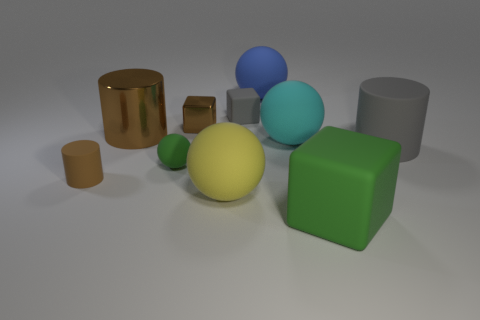There is a rubber ball to the left of the tiny brown metallic thing; is its color the same as the big block?
Your answer should be compact. Yes. There is a thing that is the same color as the big rubber block; what is its material?
Ensure brevity in your answer.  Rubber. What number of large matte objects are the same color as the small rubber ball?
Make the answer very short. 1. What is the size of the rubber object that is the same color as the small shiny object?
Your answer should be compact. Small. There is a sphere right of the big matte thing that is behind the big metal cylinder; what is its material?
Make the answer very short. Rubber. There is a large rubber object right of the cube that is to the right of the small rubber thing behind the large brown cylinder; what is its color?
Give a very brief answer. Gray. There is a object to the left of the brown cylinder right of the small cylinder; what size is it?
Your answer should be very brief. Small. What is the material of the big ball that is on the left side of the cyan rubber thing and behind the big yellow object?
Provide a short and direct response. Rubber. There is a gray matte cylinder; does it have the same size as the matte block that is on the left side of the green matte block?
Provide a short and direct response. No. Are there any brown objects?
Make the answer very short. Yes. 